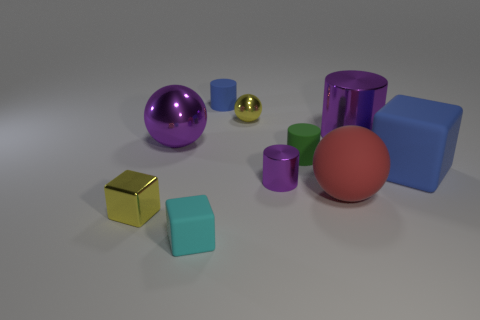The large metal object that is on the right side of the large ball that is behind the rubber block right of the small green thing is what color?
Your answer should be compact. Purple. Are there fewer large blue matte objects in front of the red object than cubes behind the big blue matte object?
Provide a succinct answer. No. Does the big red object have the same shape as the tiny blue rubber object?
Provide a succinct answer. No. How many cubes have the same size as the green thing?
Provide a succinct answer. 2. Is the number of small yellow metallic blocks that are left of the small yellow cube less than the number of large purple blocks?
Keep it short and to the point. No. There is a purple shiny sphere that is to the left of the large matte block that is right of the blue matte cylinder; what size is it?
Ensure brevity in your answer.  Large. How many objects are big blue cubes or brown objects?
Ensure brevity in your answer.  1. Are there any other shiny cylinders of the same color as the small metallic cylinder?
Your answer should be very brief. Yes. Is the number of big red objects less than the number of big brown rubber things?
Provide a short and direct response. No. What number of objects are tiny green rubber objects or objects that are to the left of the tiny purple metallic cylinder?
Your answer should be compact. 6. 